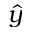Convert formula to latex. <formula><loc_0><loc_0><loc_500><loc_500>\hat { y }</formula> 